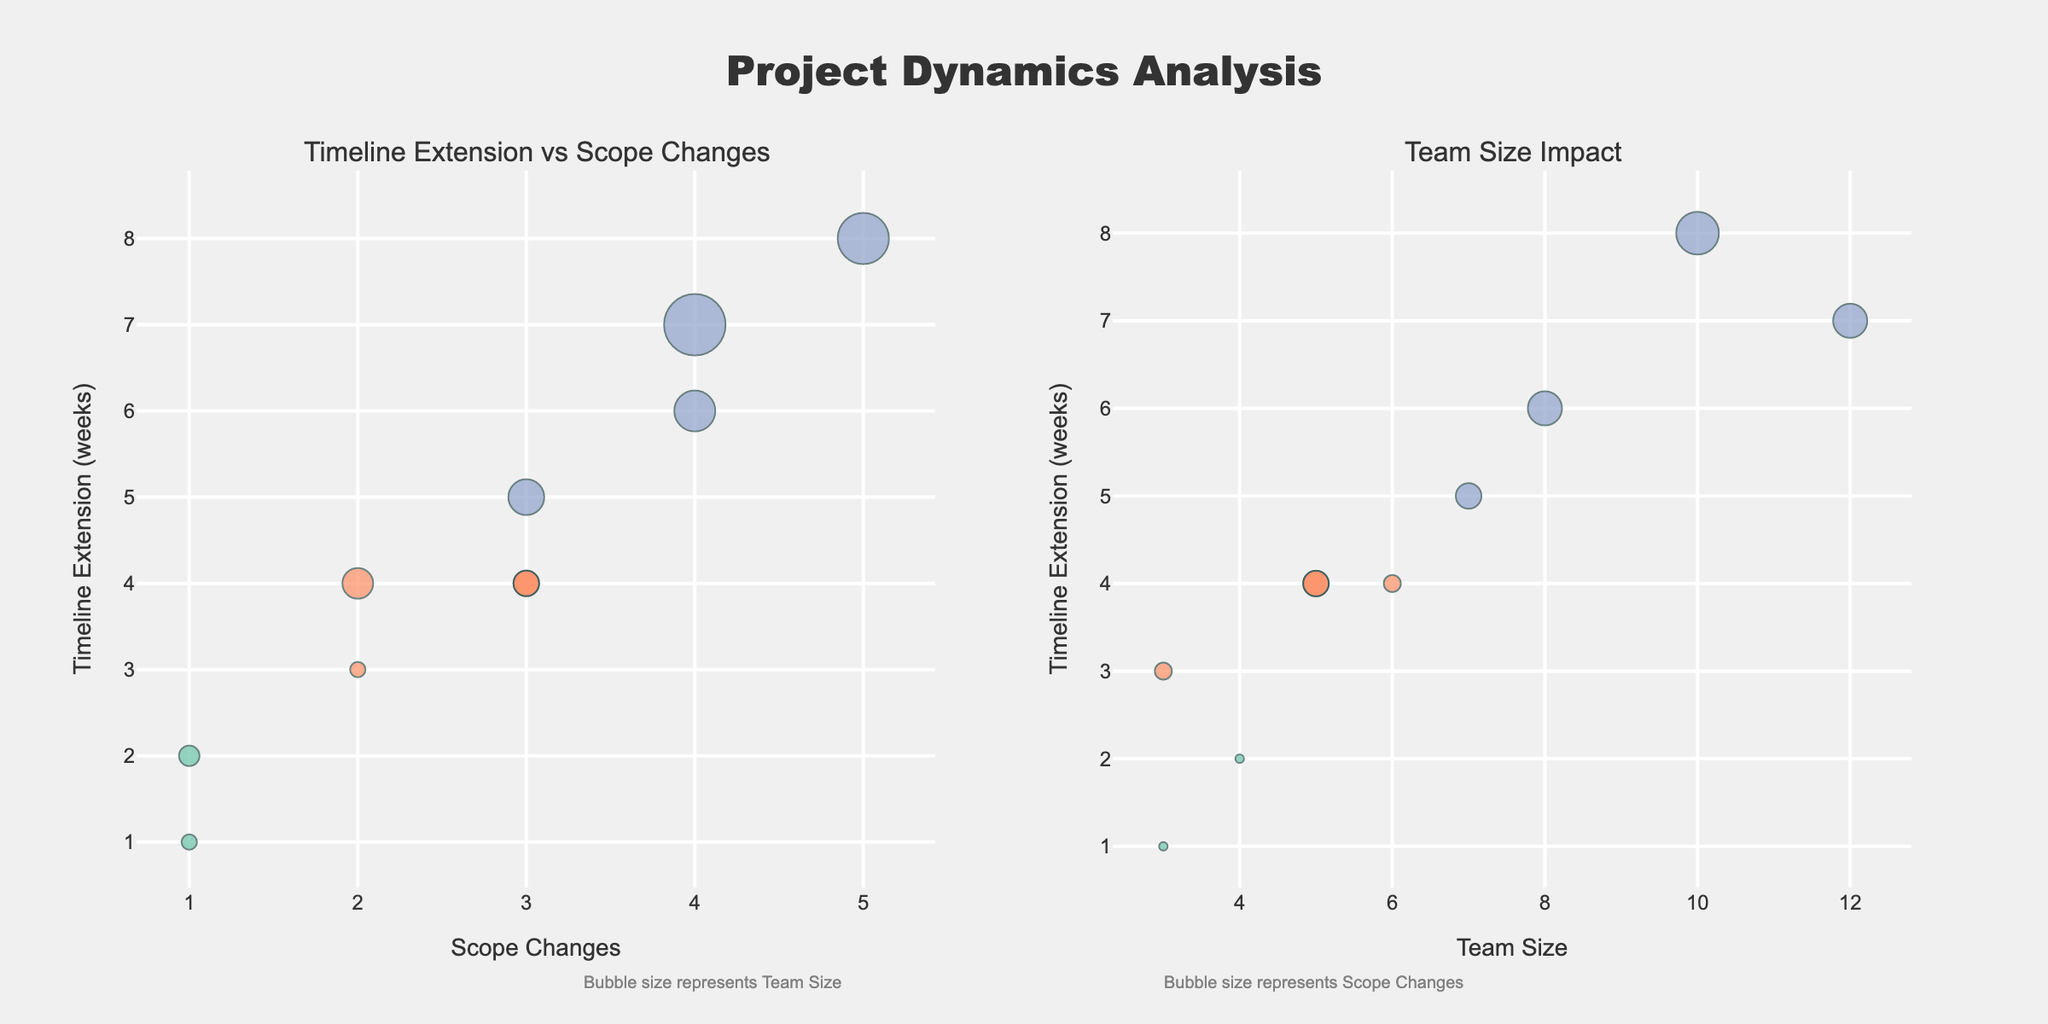Which project has the highest number of scope changes? The first subplot, "Timeline Extension vs Scope Changes," shows the number of scope changes on the x-axis. The project with the highest number of scope changes is the one plotted furthest to the right.
Answer: MobileAppDevelopment What is the relationship between team size and timeline extension in the "Team Size Impact" subplot? The "Team Size Impact" subplot shows team size on the x-axis and timeline extension on the y-axis. Observing the trend and position of the bubbles indicate that, generally, larger team sizes tend to have longer timeline extensions.
Answer: Larger teams generally have longer timeline extensions Which projects have a medium severity level in the "Timeline Extension vs Scope Changes" subplot? In the first subplot, the medium severity projects are marked with a specific color (e.g., #fc8d62). Observing the bubbles of this color, we can identify these projects.
Answer: BrandRedesign, MarketingCampaign, CorporateIdentity, SocialMediaStrategy Is there a project with a low severity level that also has a high team size? In the second subplot, check for bubbles with colors representing low severity (e.g., #66c2a5) and check their team sizes on the x-axis. None of the low severity bubbles have a high team size compared to others.
Answer: No How many projects show a timeline extension of more than 5 weeks in the "Timeline Extension vs Scope Changes" subplot? In the first subplot, scan the y-axis for values greater than 5 and count the corresponding bubbles. Projects with such extensions include WebsiteOverhaul, MobileAppDevelopment, ProductLaunch, and ECommercePlatform.
Answer: Four projects Which project has the shortest initial timeline but still extends its timeline? Identify the project with the smallest initial timeline that isn't a hazard bubble, and cross-check with any timeline extension. The "InitialTimeline" doesn't directly appear in the plot, but the shortest total timeline is SEOOptimization which has an extension.
Answer: SEOOptimization How do the bubble sizes vary between subplots, and what do they represent? In the first subplot, bubble size represents team size, while in the second subplot, bubble size represents the number of scope changes. This variation helps compare how different factors impact timeline extension.
Answer: Bubble size represents different factors in each subplot What is the most significant factor contributing to extending the timeline for the MarketingCampaign project? For the MarketingCampaign project visible in both subplots, consider the scope changes as shown in the first and then check the team size in the second. Both factors are low, but the changes likely play a more critical role.
Answer: Scope changes Which project shows the largest bubble size in the "Team Size Impact" subplot, and what does that indicate? Identify the project with the largest bubble in the second subplot. This reflects its substantial number of scope changes, irrespective of the team size. The MobileAppDevelopment project stands out.
Answer: MobileAppDevelopment Are there any low-severity projects that do not extend their timelines significantly despite multiple scope changes? In the first subplot, observe the positioning of low-severity colored bubbles relative to the x (scope changes) and y (timeline extension) axes. UXImprovement demonstrates minimal extension despite some changes.
Answer: UXImprovement 